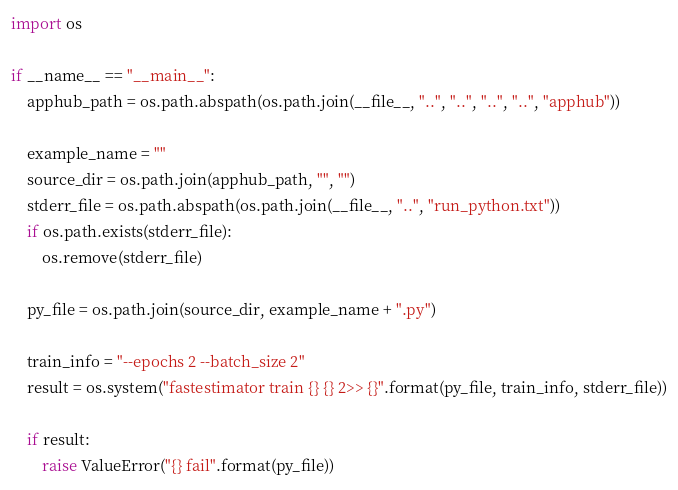Convert code to text. <code><loc_0><loc_0><loc_500><loc_500><_Python_>import os

if __name__ == "__main__":
    apphub_path = os.path.abspath(os.path.join(__file__, "..", "..", "..", "..", "apphub"))

    example_name = ""
    source_dir = os.path.join(apphub_path, "", "")
    stderr_file = os.path.abspath(os.path.join(__file__, "..", "run_python.txt"))
    if os.path.exists(stderr_file):
        os.remove(stderr_file)
        
    py_file = os.path.join(source_dir, example_name + ".py")

    train_info = "--epochs 2 --batch_size 2"
    result = os.system("fastestimator train {} {} 2>> {}".format(py_file, train_info, stderr_file))

    if result:
        raise ValueError("{} fail".format(py_file))
</code> 